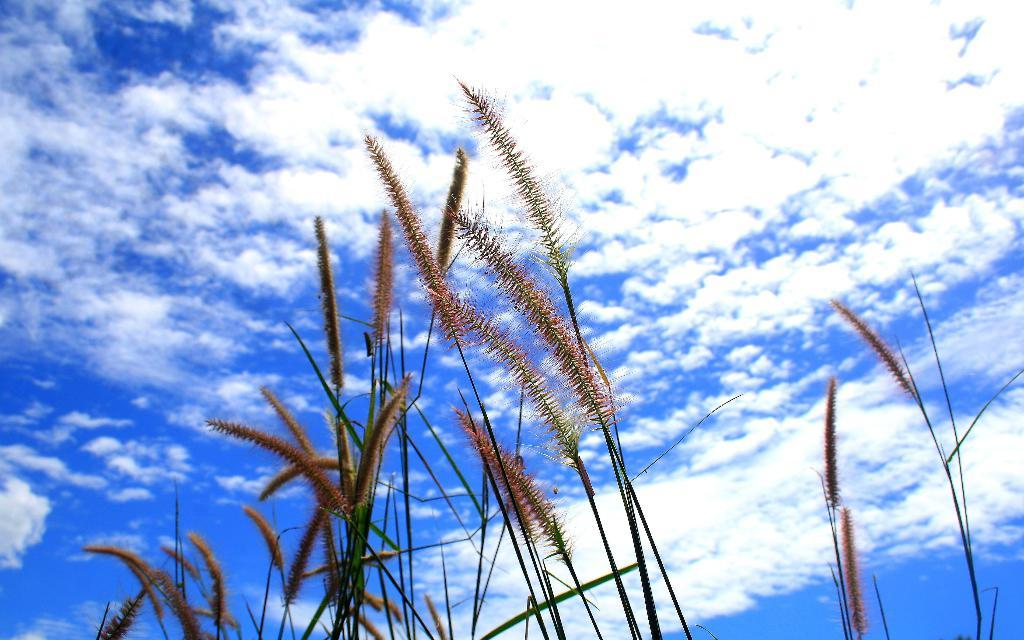What type of vegetation can be seen in the image? There is grass in the image. What is visible in the background of the image? The sky is visible in the background of the image. What can be observed in the sky? Clouds are present in the sky. What type of structure is being built by the clouds in the image? There is no structure being built by the clouds in the image; the clouds are simply present in the sky. 